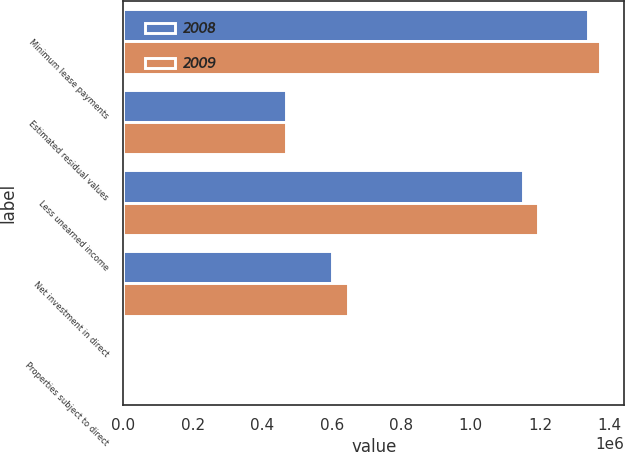Convert chart to OTSL. <chart><loc_0><loc_0><loc_500><loc_500><stacked_bar_chart><ecel><fcel>Minimum lease payments<fcel>Estimated residual values<fcel>Less unearned income<fcel>Net investment in direct<fcel>Properties subject to direct<nl><fcel>2008<fcel>1.33863e+06<fcel>467248<fcel>1.15085e+06<fcel>600077<fcel>30<nl><fcel>2009<fcel>1.37328e+06<fcel>467248<fcel>1.1923e+06<fcel>648234<fcel>30<nl></chart> 